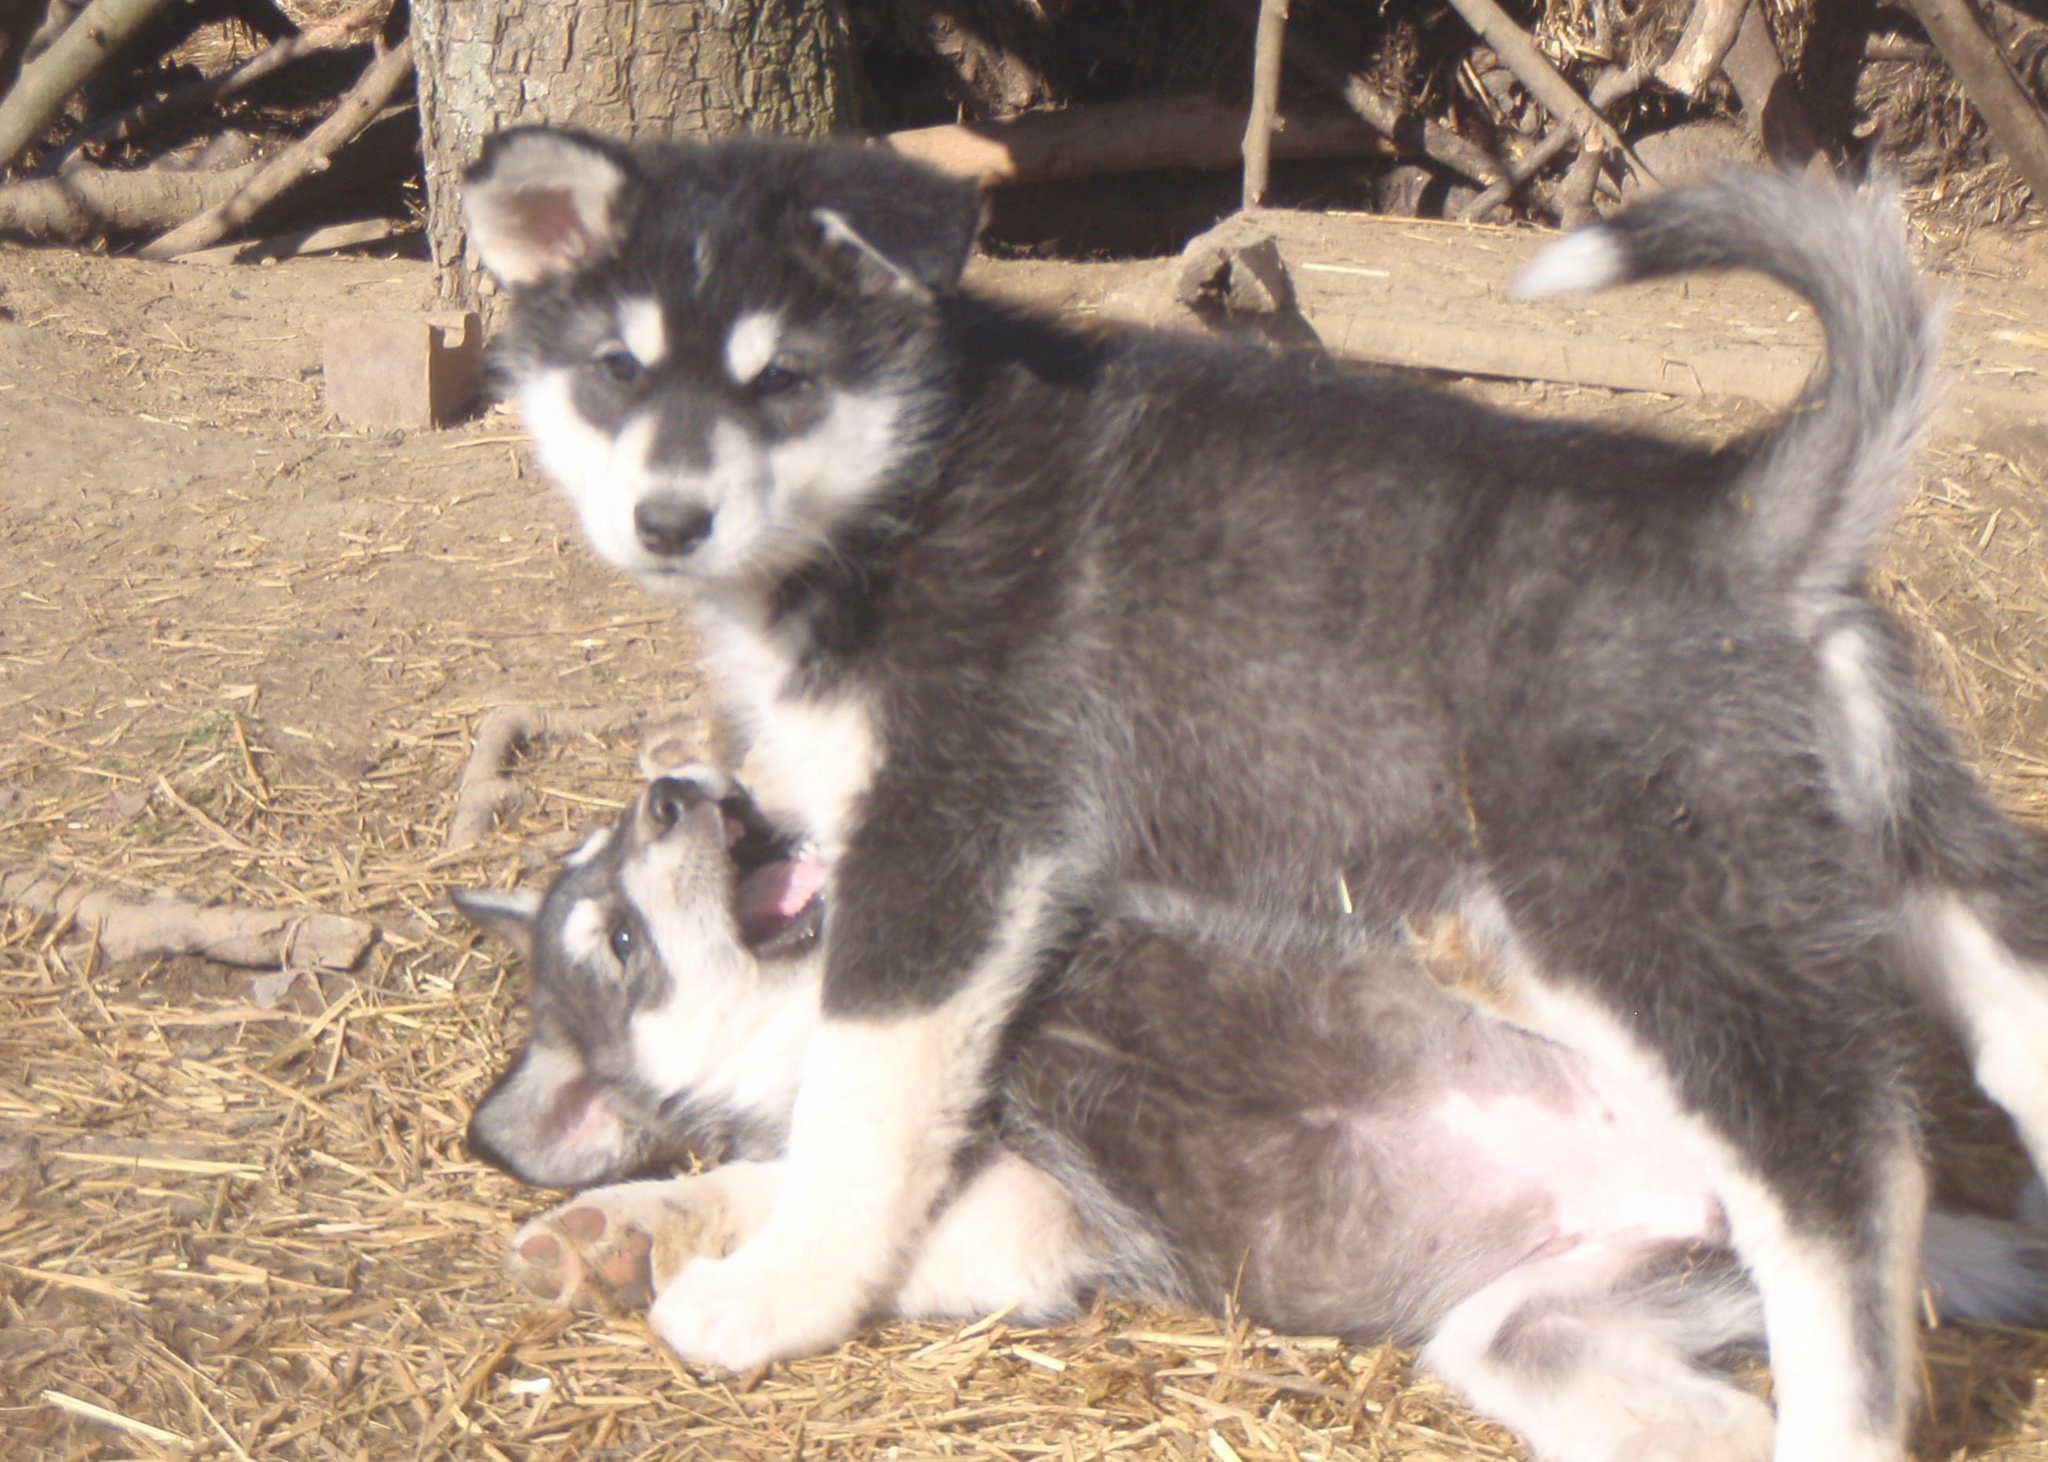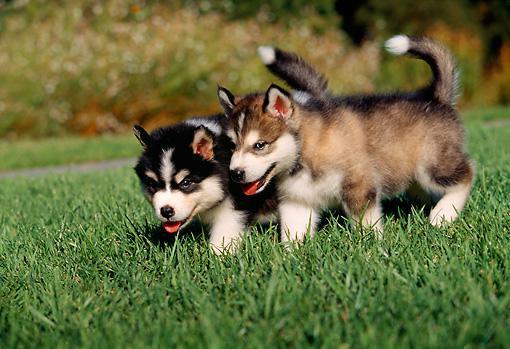The first image is the image on the left, the second image is the image on the right. For the images displayed, is the sentence "Each image shows two dogs interacting outdoors, and one image contains two gray-and-white husky dogs." factually correct? Answer yes or no. Yes. 